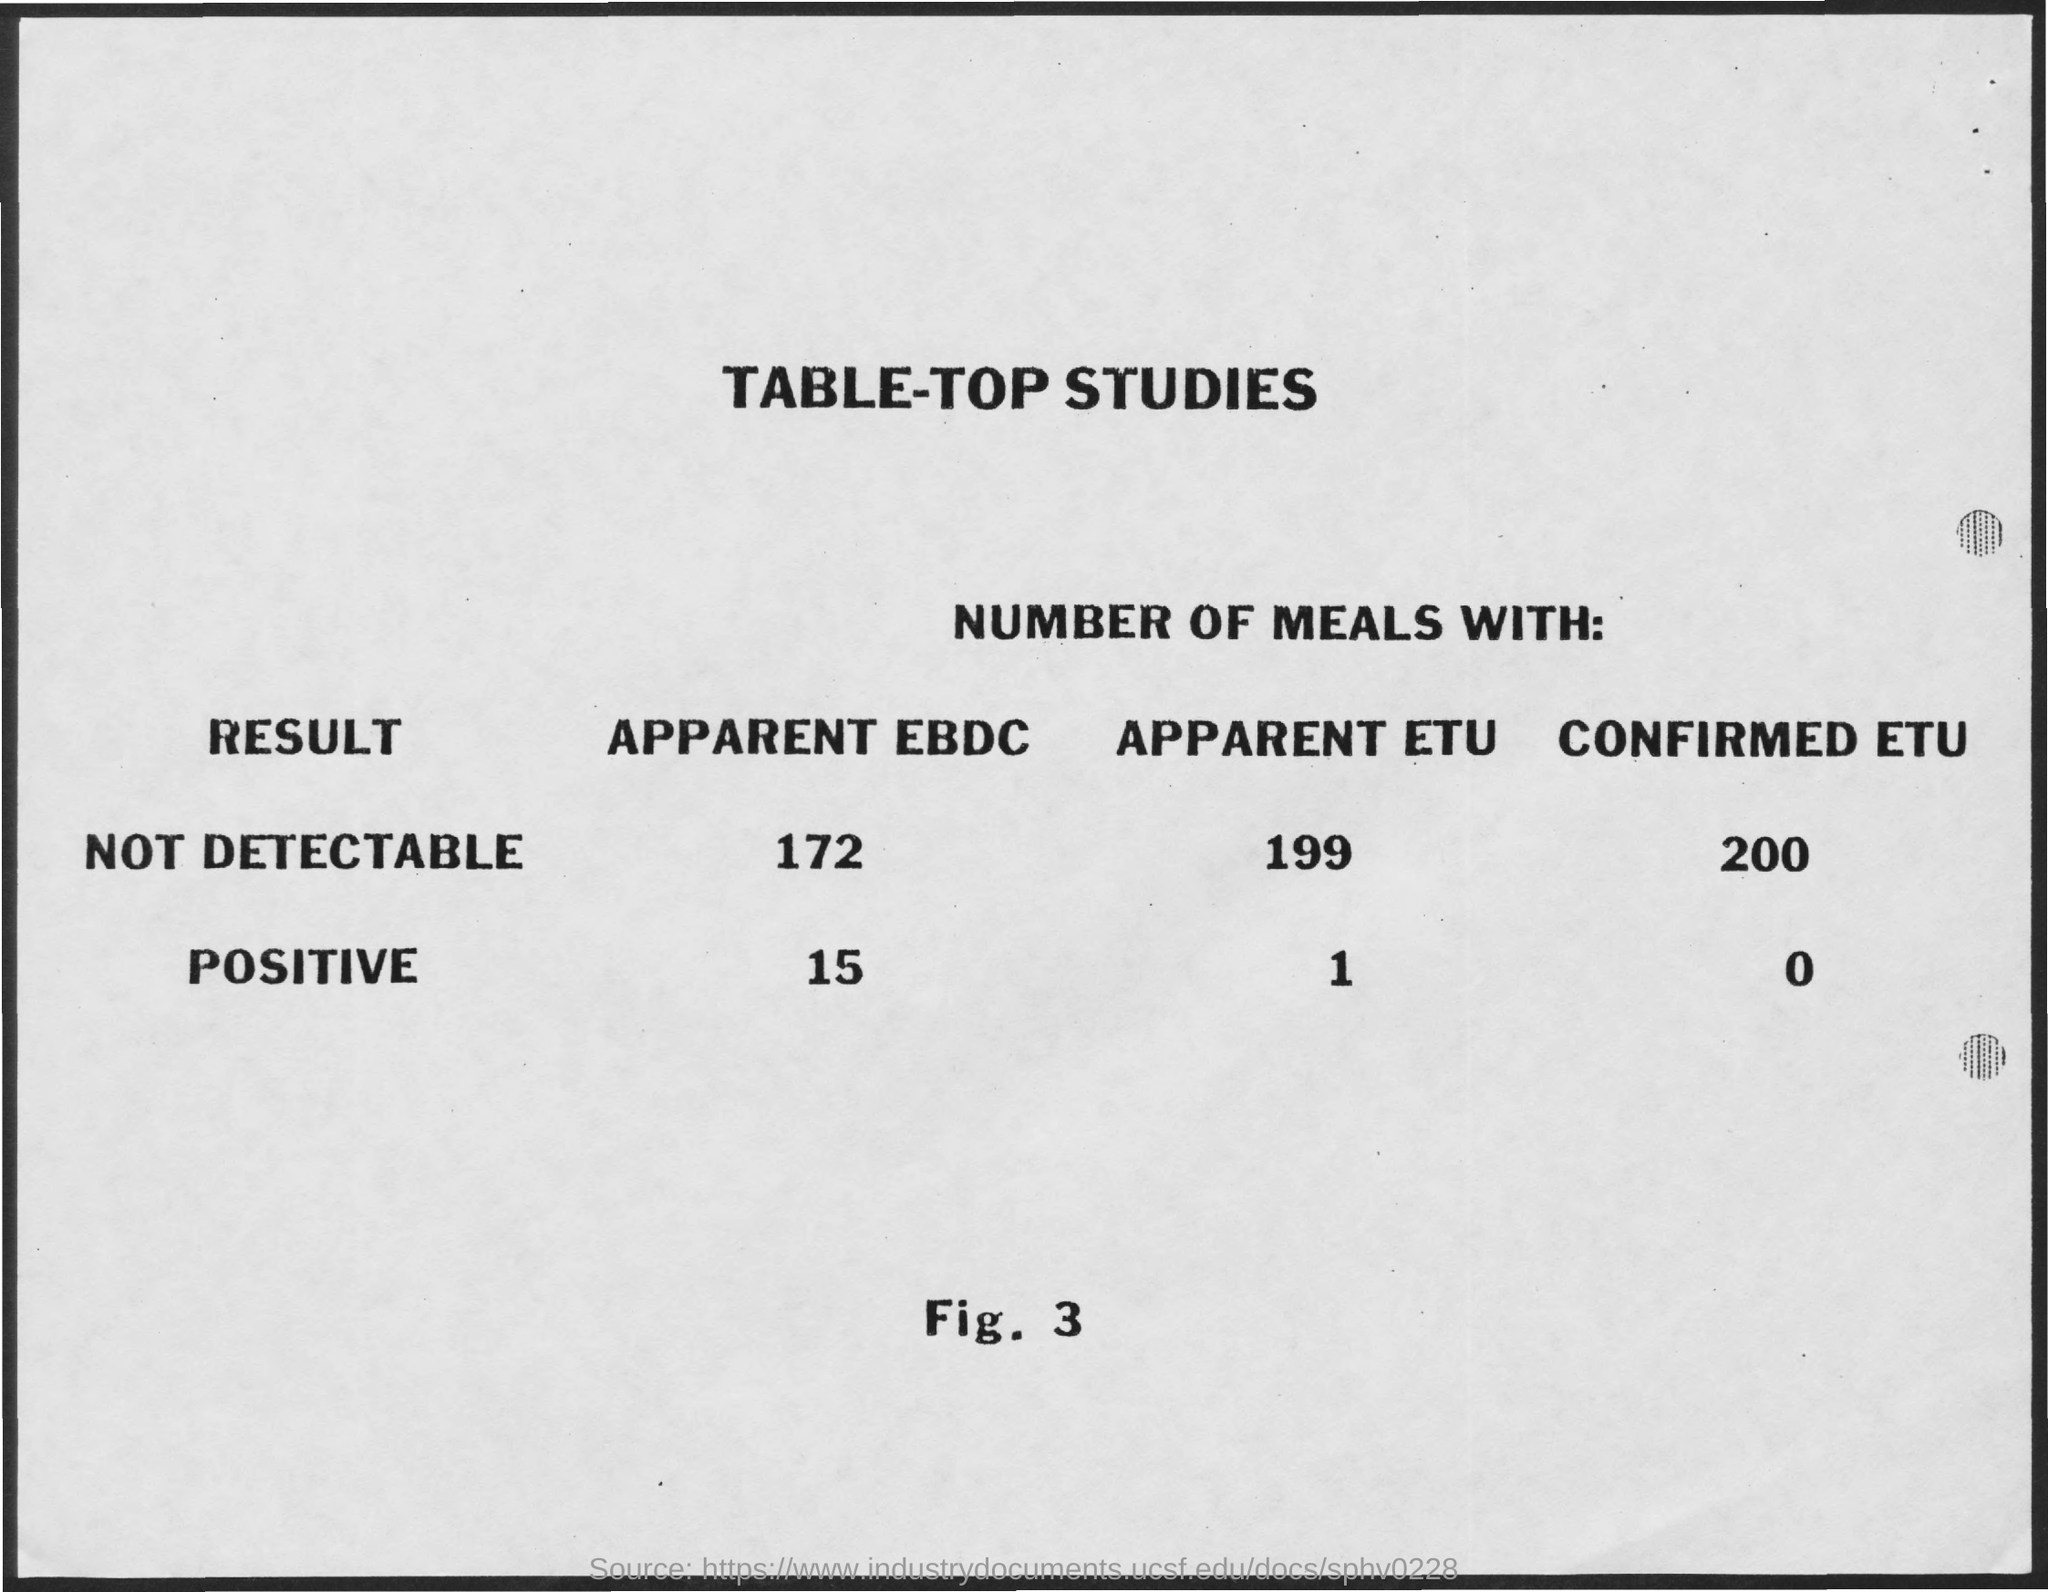Draw attention to some important aspects in this diagram. The result of not detecting apparent EBD-C (172...) is unknown. The result of a not detectable apparent ethnicity is unknown, with a reported value of 199... 